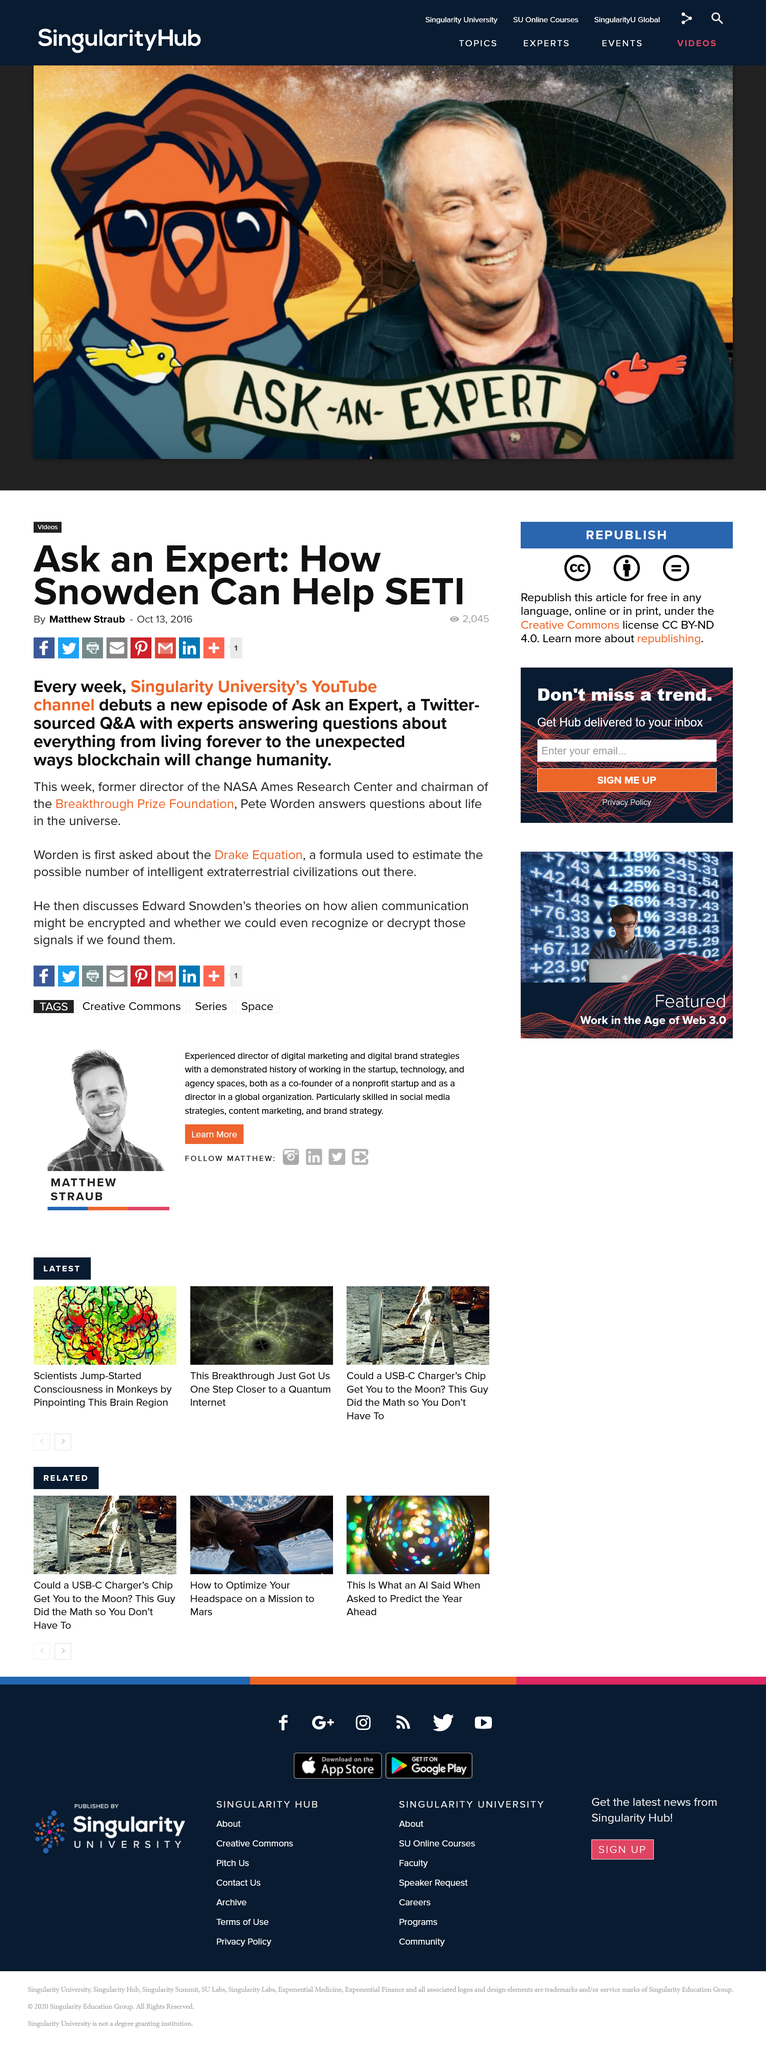Mention a couple of crucial points in this snapshot. The "Ask An Expert: How Snowden Can Help SETI" article has 2,045 views. Matthew Straub wrote the "Ask an Expert: How Snowden Can Help SETI" article. The article was published on October 13th, 2016. 